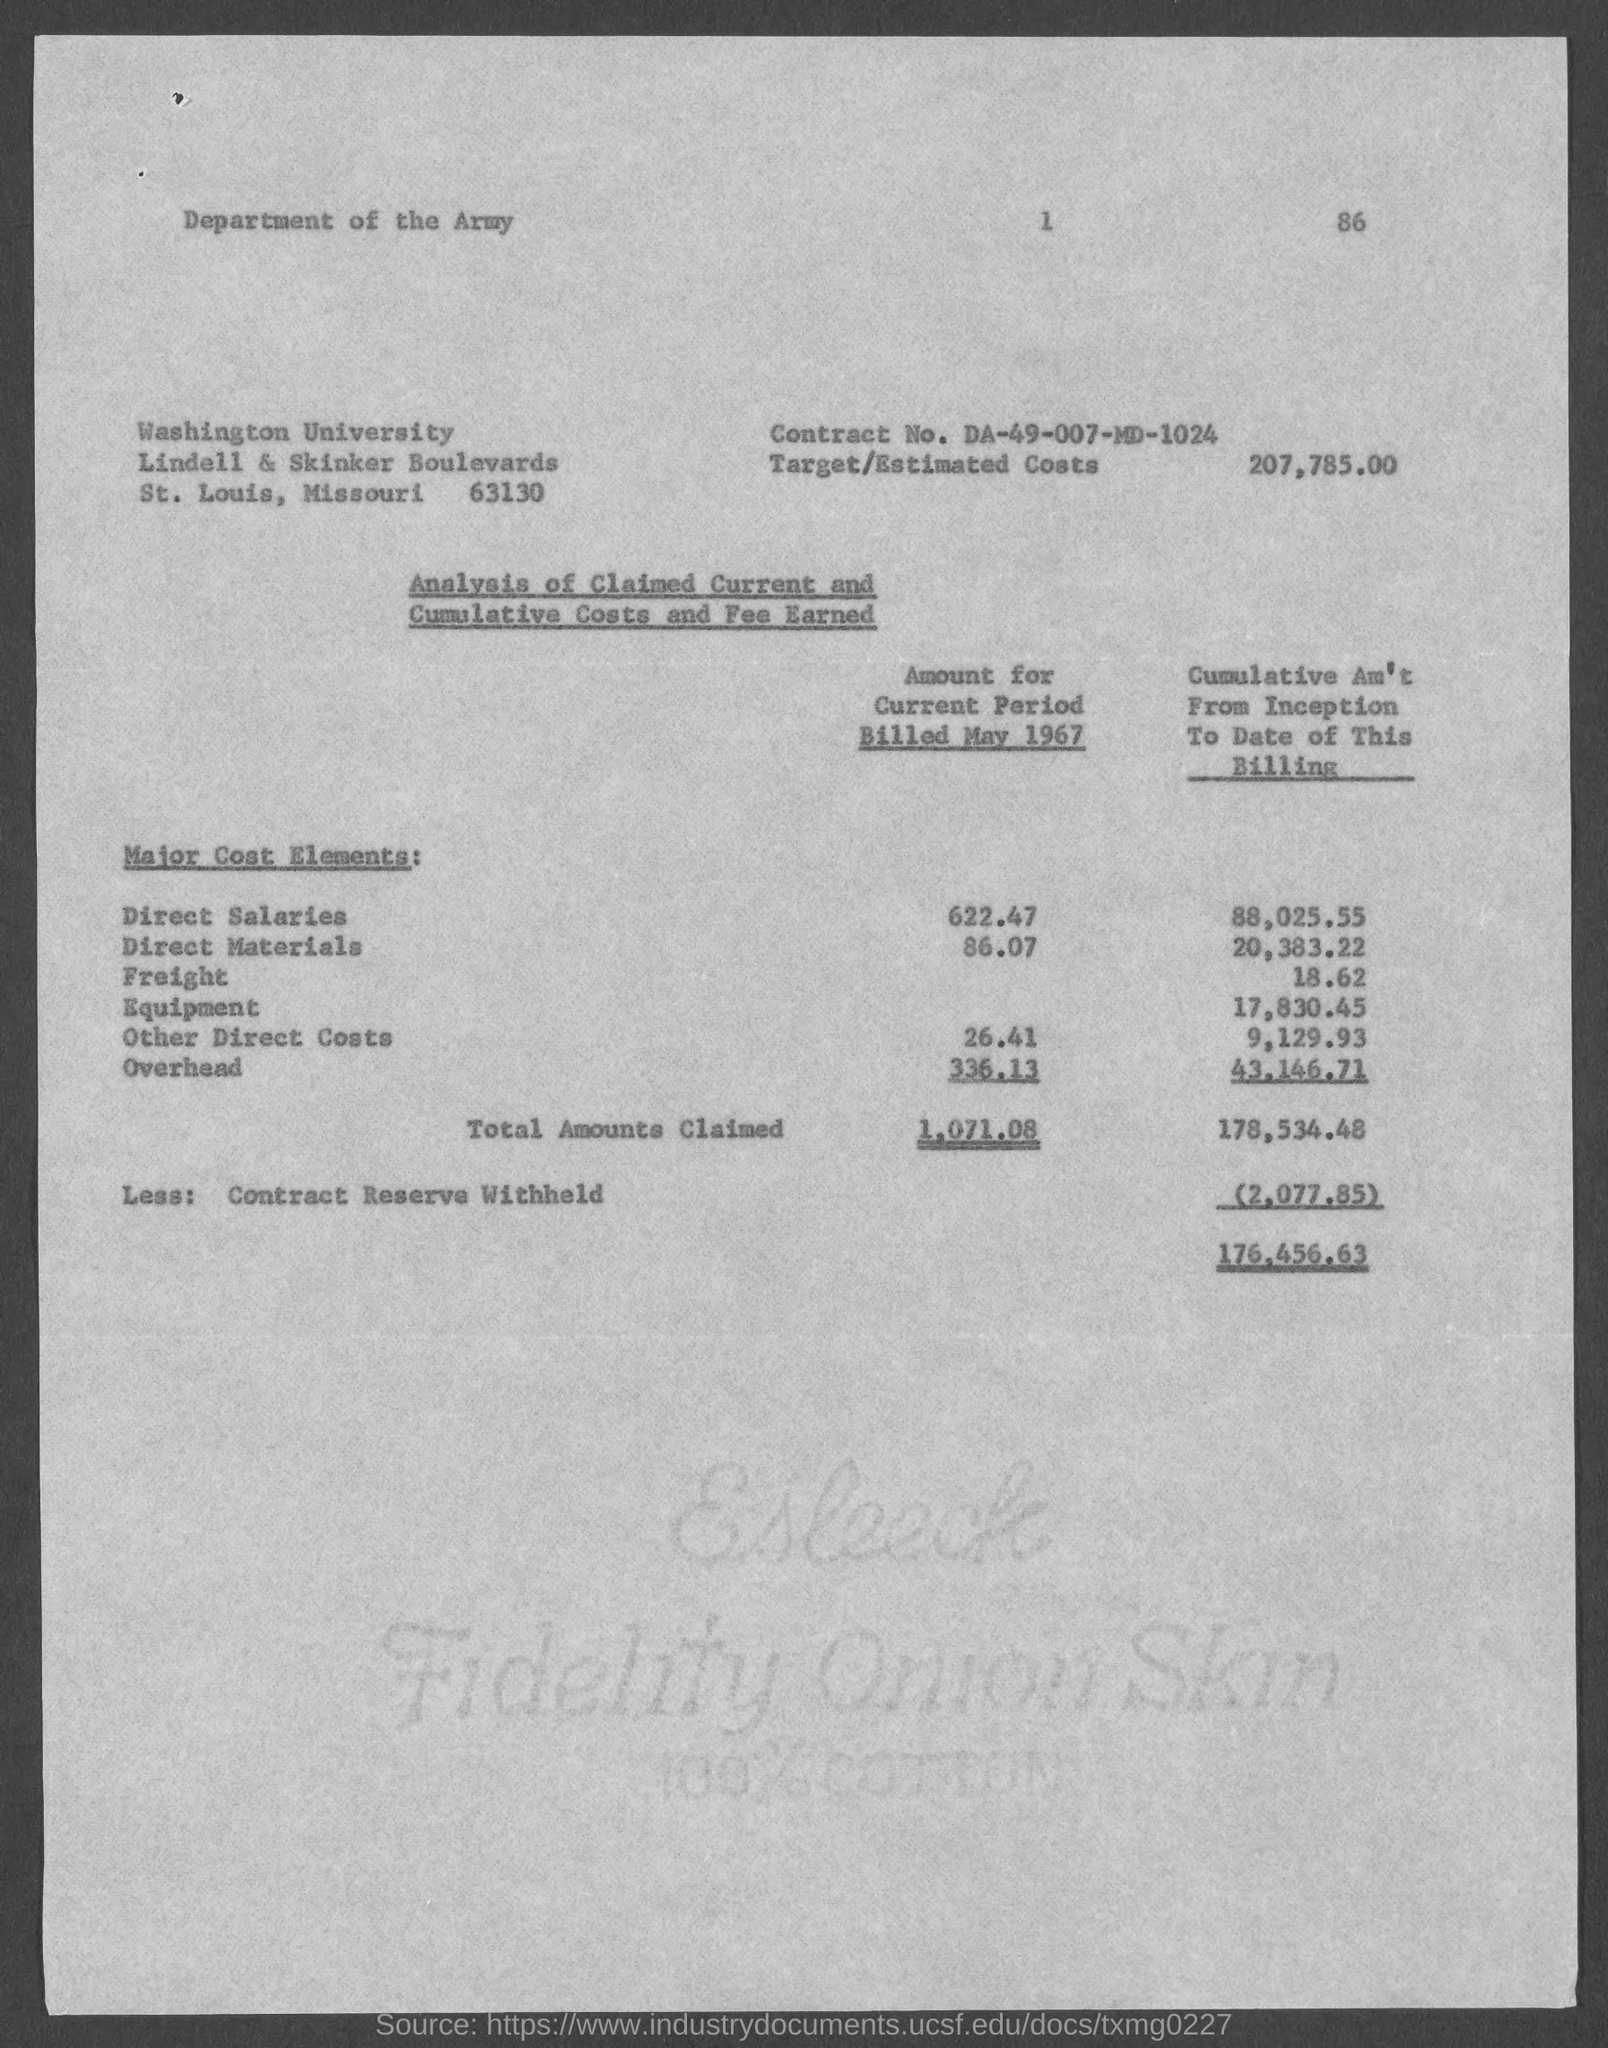List a handful of essential elements in this visual. The targeted costs are estimated to be 207,785.00. Washington University is located in the state of Missouri. The amount for the current period billed in May 1967 for Direct Salaries is 622.47. The amount for the current period billed in May 1967 for direct materials was $86.07. The amount for the current period billed in May 1967 for overhead was $336.13. 